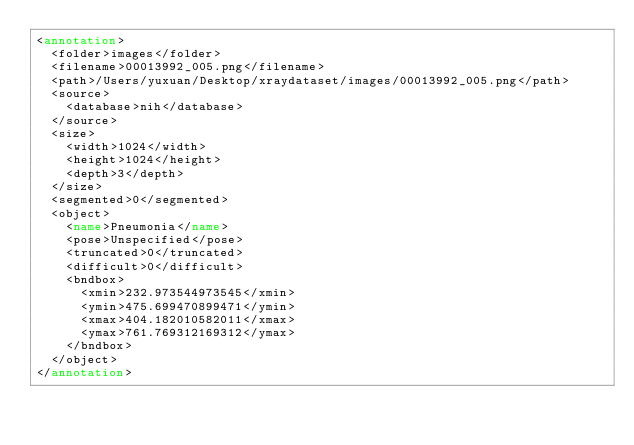<code> <loc_0><loc_0><loc_500><loc_500><_XML_><annotation>
	<folder>images</folder>
	<filename>00013992_005.png</filename>
	<path>/Users/yuxuan/Desktop/xraydataset/images/00013992_005.png</path>
	<source>
		<database>nih</database>
	</source>
	<size>
		<width>1024</width>
		<height>1024</height>
		<depth>3</depth>
	</size>
	<segmented>0</segmented>
	<object>
		<name>Pneumonia</name>
		<pose>Unspecified</pose>
		<truncated>0</truncated>
		<difficult>0</difficult>
		<bndbox>
			<xmin>232.973544973545</xmin>
			<ymin>475.699470899471</ymin>
			<xmax>404.182010582011</xmax>
			<ymax>761.769312169312</ymax>
		</bndbox>
	</object>
</annotation></code> 